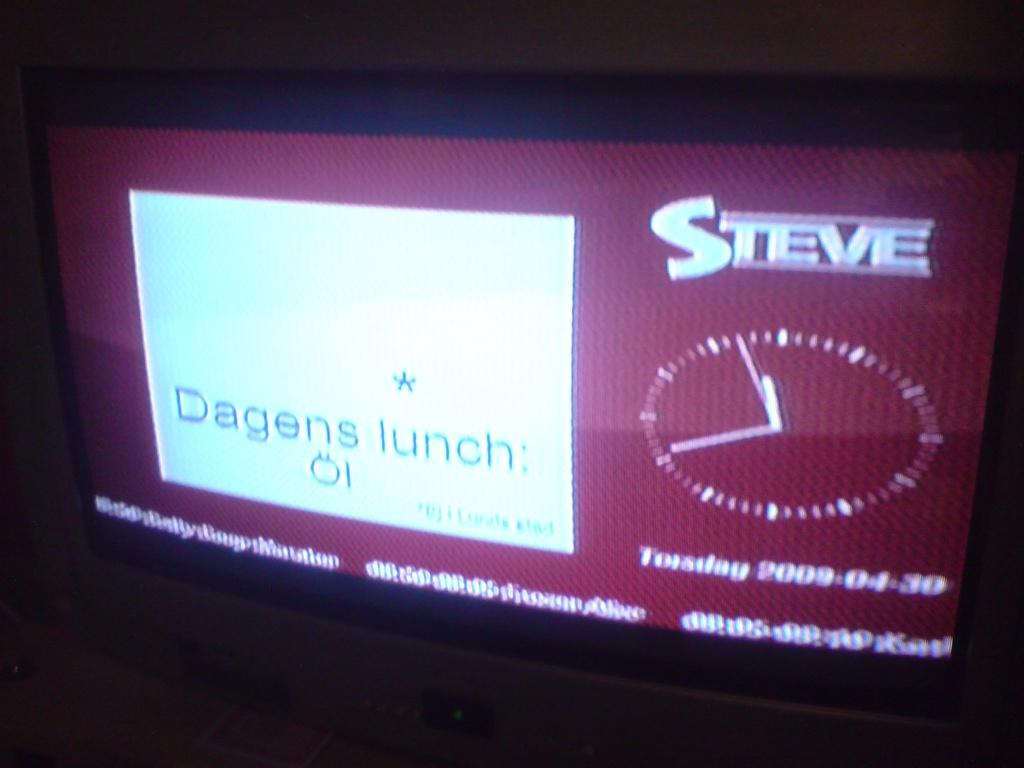<image>
Relay a brief, clear account of the picture shown. A TV screen that says Steve  in the upper right corner. 